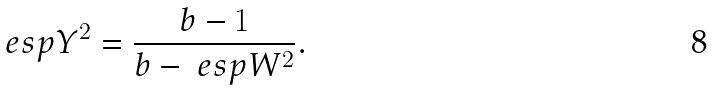Convert formula to latex. <formula><loc_0><loc_0><loc_500><loc_500>\ e s p { Y ^ { 2 } } = \frac { b - 1 } { b - \ e s p { W ^ { 2 } } } .</formula> 